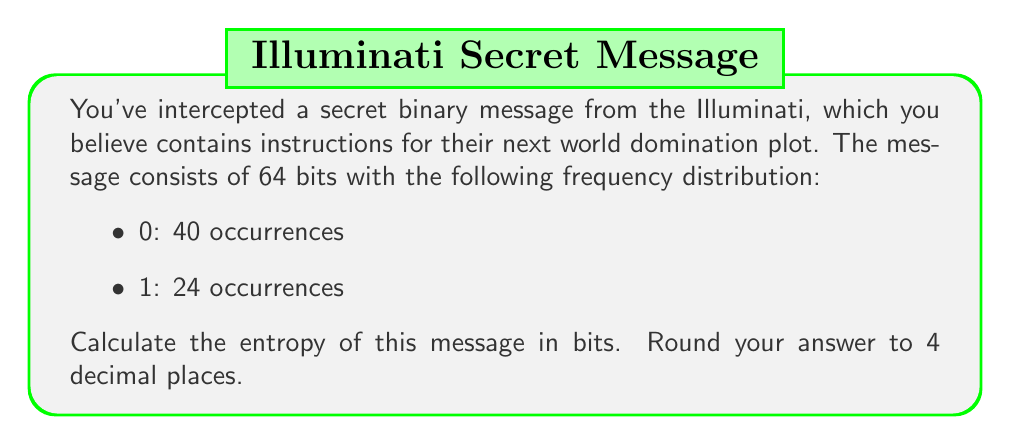What is the answer to this math problem? To calculate the entropy of the binary message, we'll use Shannon's entropy formula:

$$H = -\sum_{i=1}^n p_i \log_2(p_i)$$

Where:
$H$ is the entropy in bits
$p_i$ is the probability of each symbol (0 or 1 in this case)
$n$ is the number of distinct symbols (2 in binary)

Step 1: Calculate the probabilities
Total bits: 40 + 24 = 64
$p_0 = \frac{40}{64} = \frac{5}{8} = 0.625$
$p_1 = \frac{24}{64} = \frac{3}{8} = 0.375$

Step 2: Apply the entropy formula
$$\begin{align}
H &= -[p_0 \log_2(p_0) + p_1 \log_2(p_1)] \\
&= -[\frac{5}{8} \log_2(\frac{5}{8}) + \frac{3}{8} \log_2(\frac{3}{8})] \\
&= -[0.625 \cdot (-0.6780719051126377) + 0.375 \cdot (-1.4150374992788438)] \\
&= 0.4237949407 + 0.5306390622 \\
&= 0.9544340029
\end{align}$$

Step 3: Round to 4 decimal places
$H \approx 0.9544$ bits
Answer: 0.9544 bits 